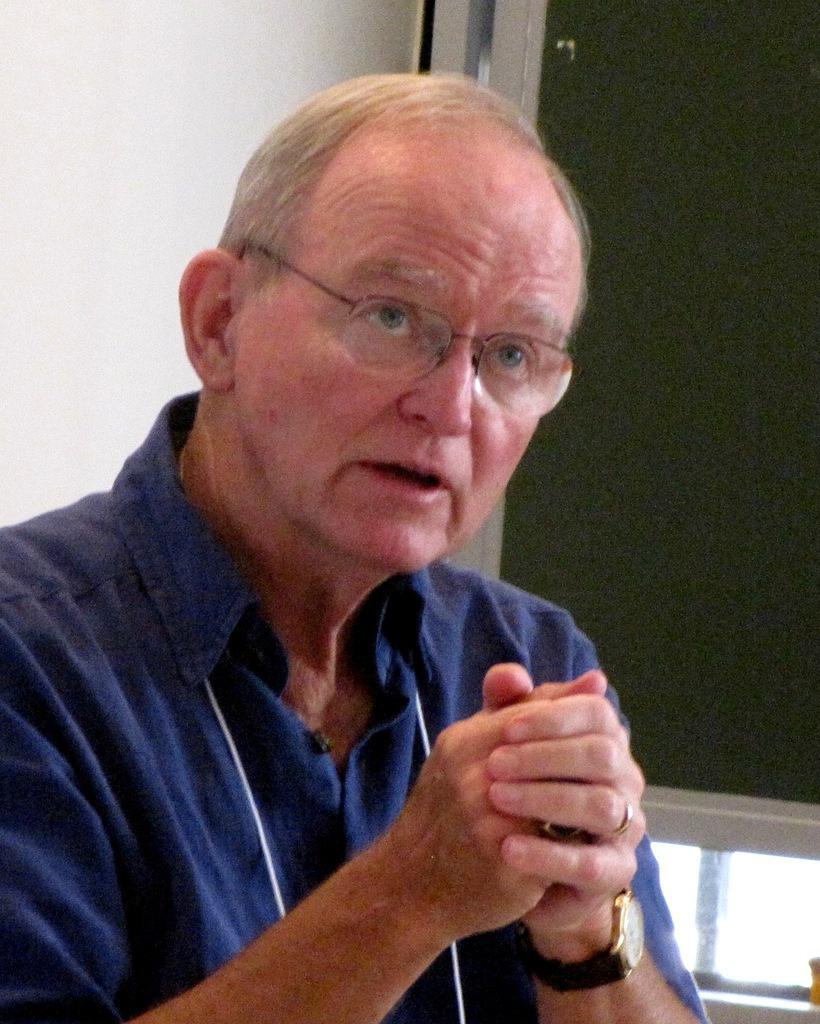Can you describe this image briefly? In this image I can see a man in the front and I can see he is wearing blue colour dress, a watch and a specs. In the background I can see a green colour board. 